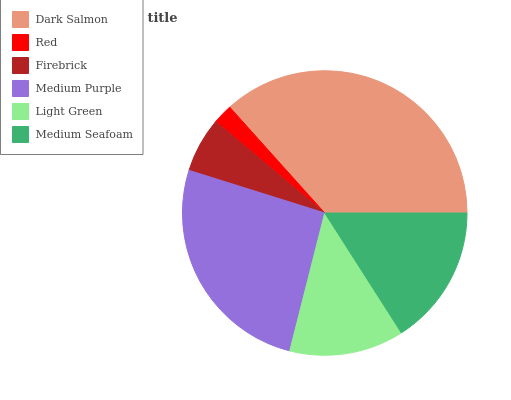Is Red the minimum?
Answer yes or no. Yes. Is Dark Salmon the maximum?
Answer yes or no. Yes. Is Firebrick the minimum?
Answer yes or no. No. Is Firebrick the maximum?
Answer yes or no. No. Is Firebrick greater than Red?
Answer yes or no. Yes. Is Red less than Firebrick?
Answer yes or no. Yes. Is Red greater than Firebrick?
Answer yes or no. No. Is Firebrick less than Red?
Answer yes or no. No. Is Medium Seafoam the high median?
Answer yes or no. Yes. Is Light Green the low median?
Answer yes or no. Yes. Is Red the high median?
Answer yes or no. No. Is Medium Purple the low median?
Answer yes or no. No. 